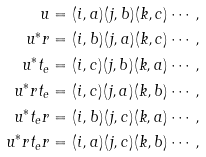<formula> <loc_0><loc_0><loc_500><loc_500>u & = ( i , a ) ( j , b ) ( k , c ) \cdots , \\ u ^ { * } r & = ( i , b ) ( j , a ) ( k , c ) \cdots , \\ u ^ { * } t _ { e } & = ( i , c ) ( j , b ) ( k , a ) \cdots , \\ u ^ { * } r t _ { e } & = ( i , c ) ( j , a ) ( k , b ) \cdots , \\ u ^ { * } t _ { e } r & = ( i , b ) ( j , c ) ( k , a ) \cdots , \\ u ^ { * } r t _ { e } r & = ( i , a ) ( j , c ) ( k , b ) \cdots ,</formula> 